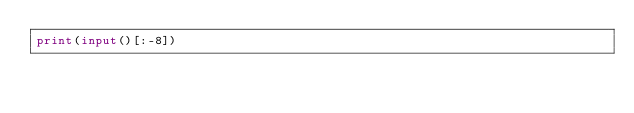Convert code to text. <code><loc_0><loc_0><loc_500><loc_500><_Python_>print(input()[:-8])</code> 